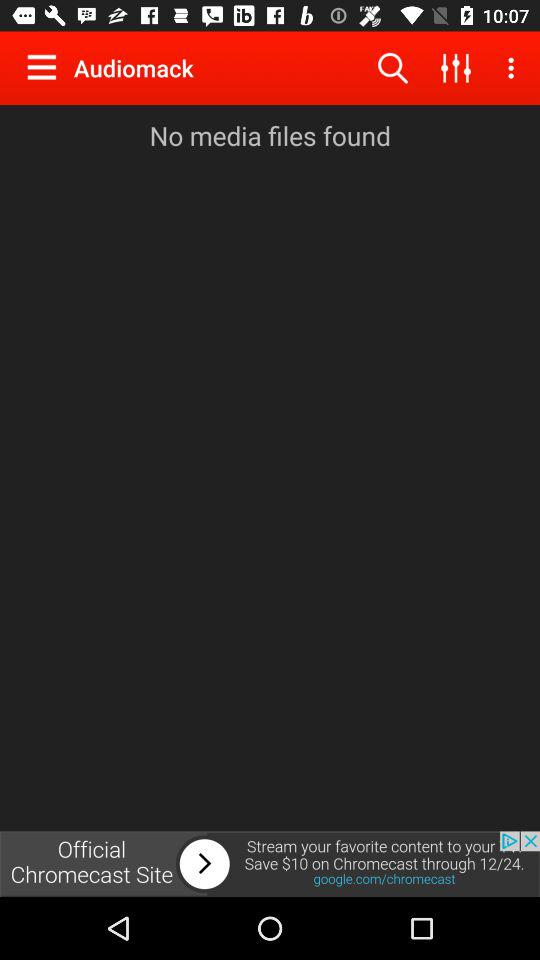What is the application name? The application name is "Audiomack". 